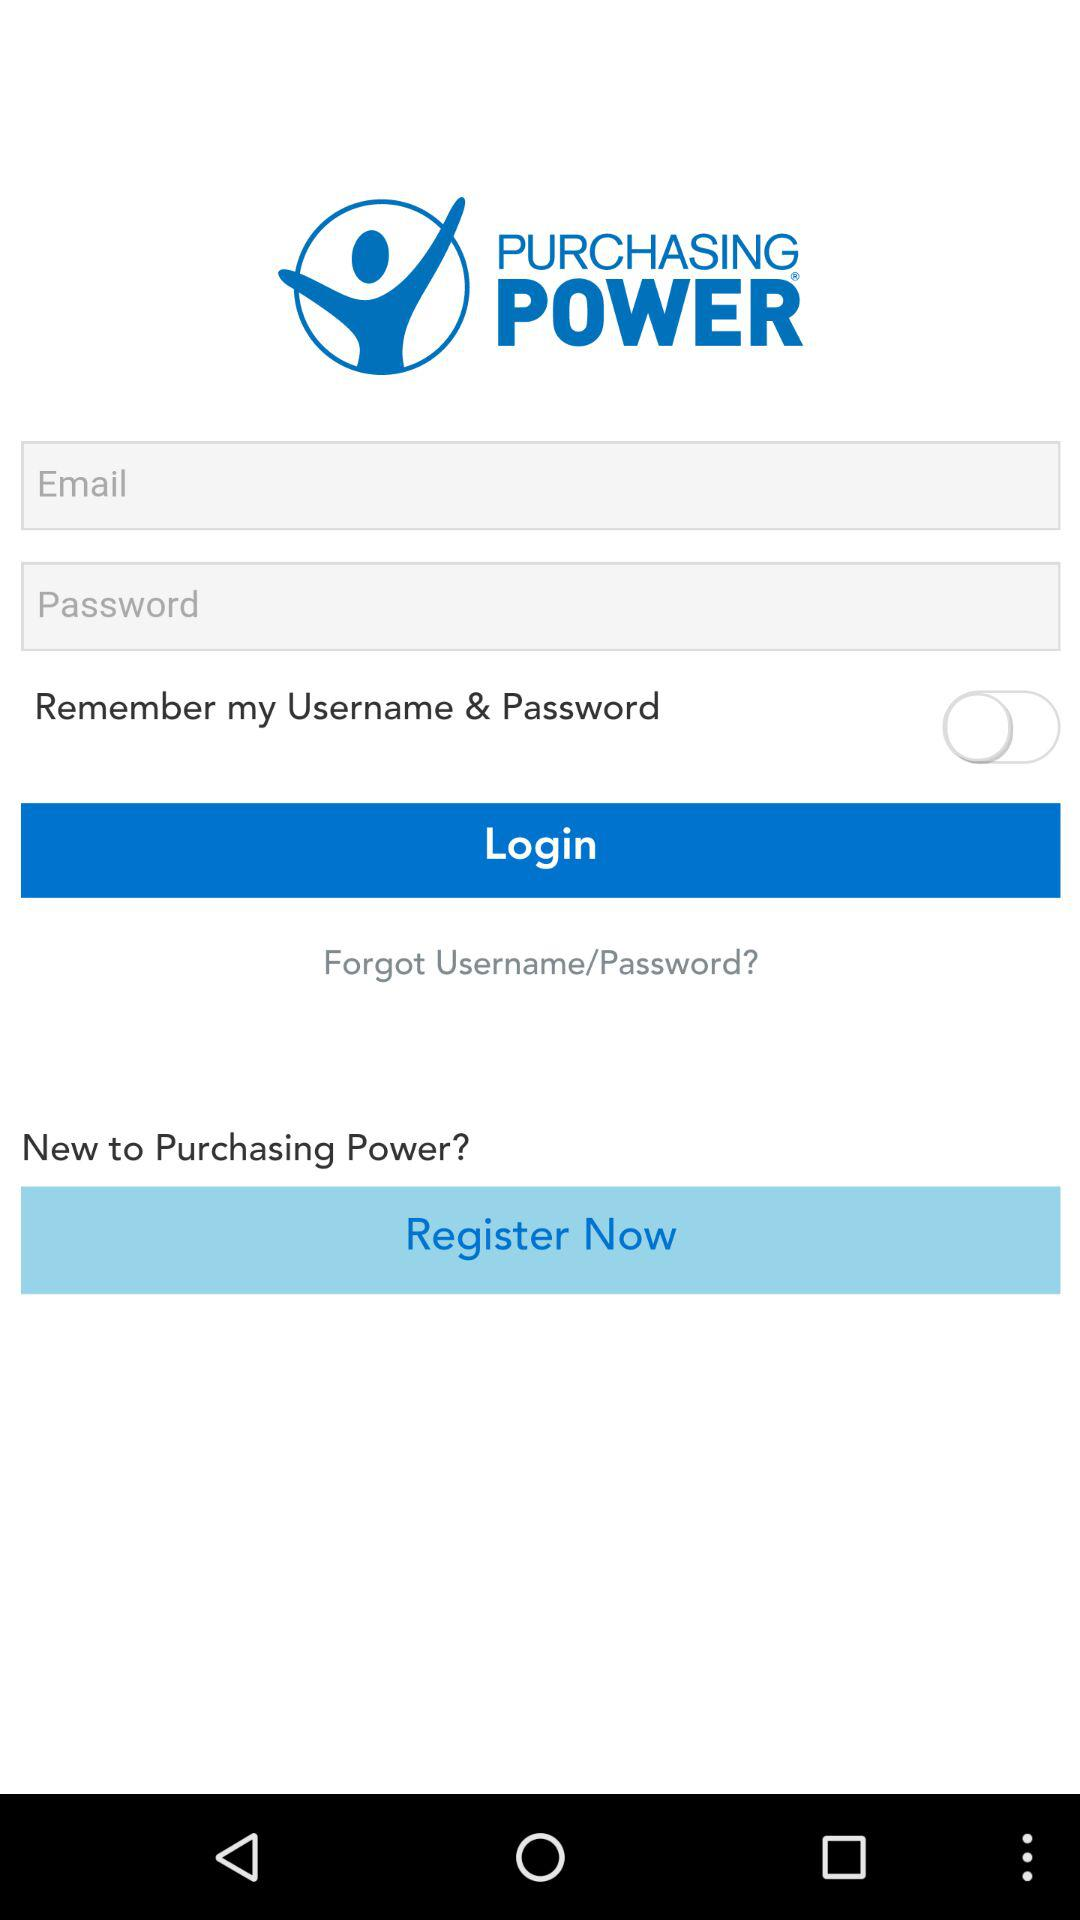What is the name of the application? The name of the application is "PURCHASING POWER". 